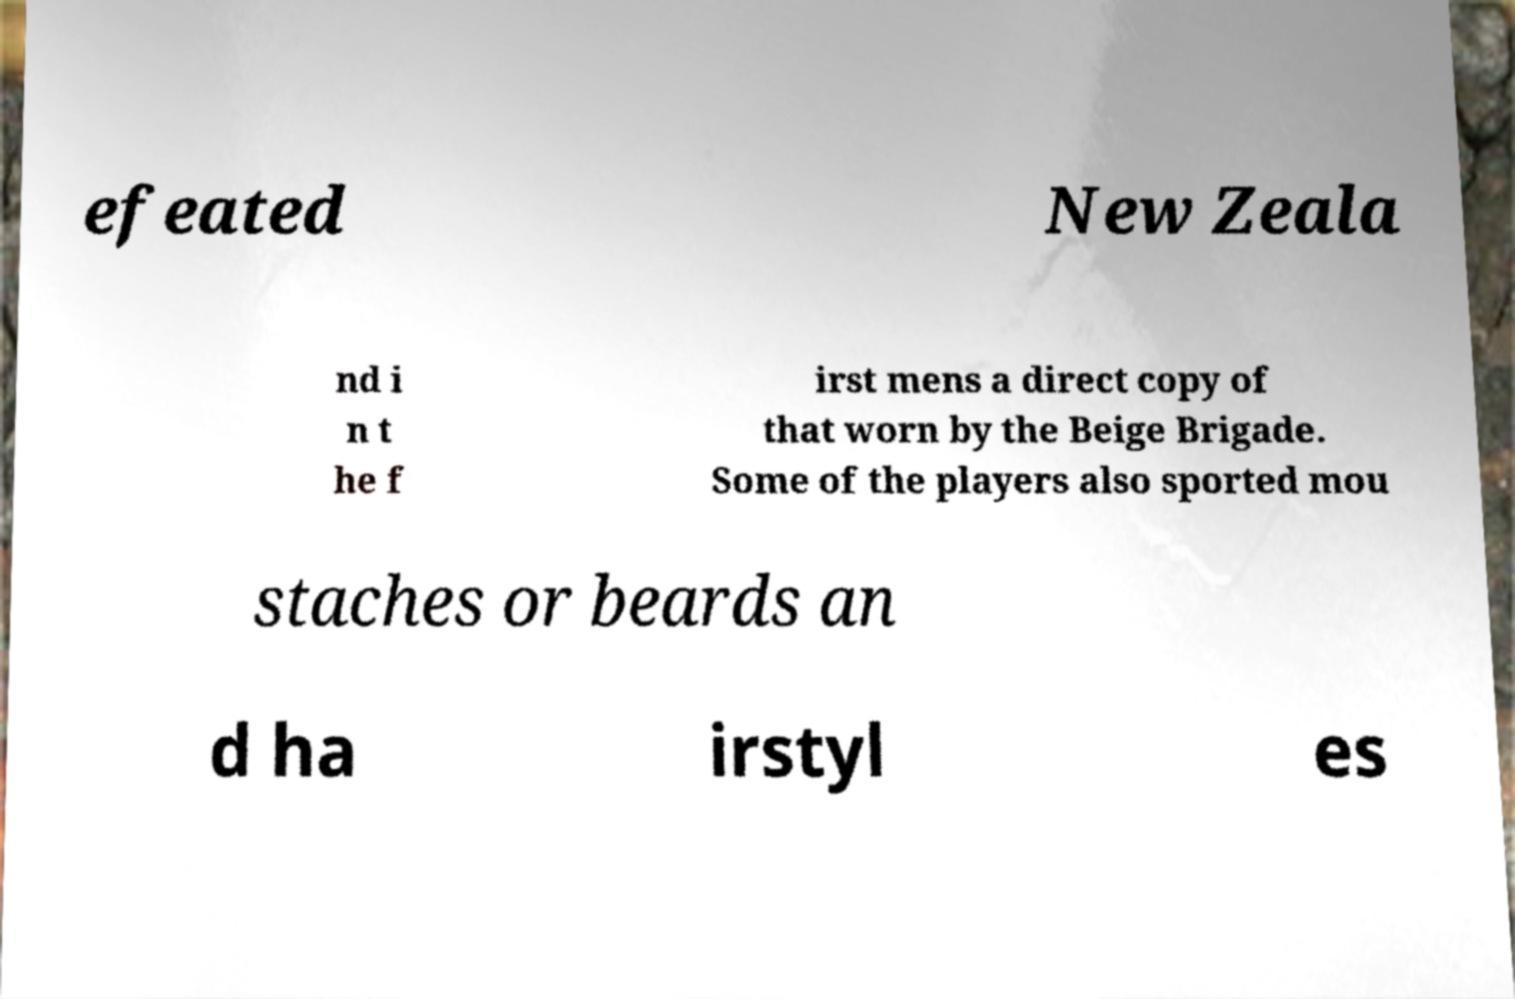For documentation purposes, I need the text within this image transcribed. Could you provide that? efeated New Zeala nd i n t he f irst mens a direct copy of that worn by the Beige Brigade. Some of the players also sported mou staches or beards an d ha irstyl es 